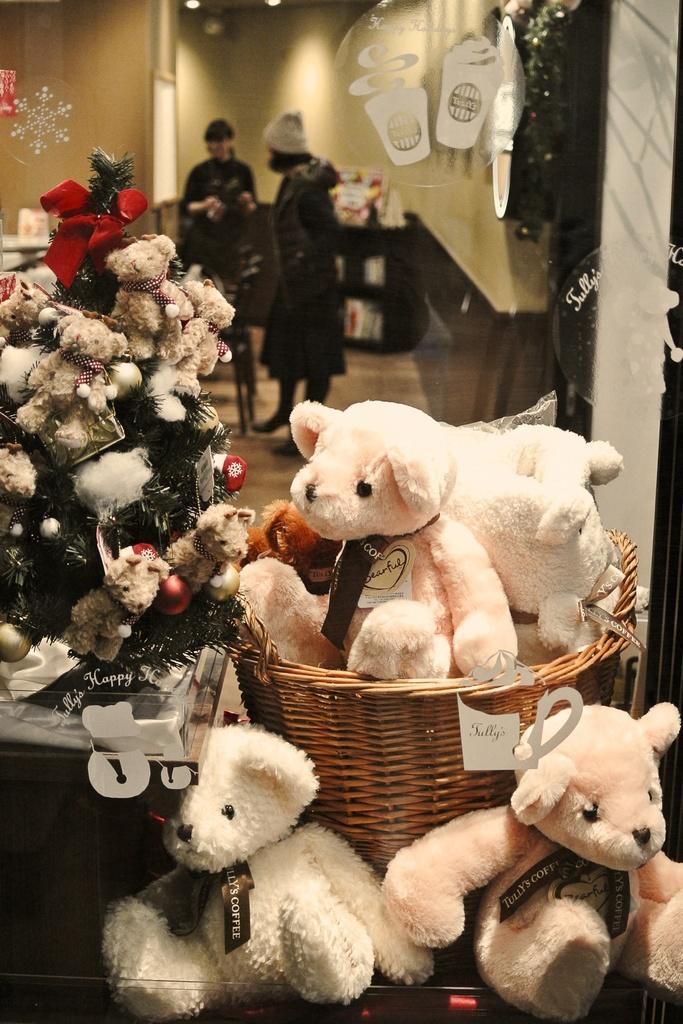What can be seen in the image related to toys or dolls? There is a group of dolls in the image. What object is present that could be used for holding or carrying items? There is a basket in the image. What is the tree in the image decorated with? The tree in the image is decorated with toys and a ribbon. What type of structure is visible in the background of the image? There is a wall visible in the image. What is the position of the people in the image? There are people standing on the floor in the image. What date is marked on the calendar in the image? There is no calendar present in the image. How many feet are visible in the image? The image does not show any feet; it only shows people standing on the floor. 